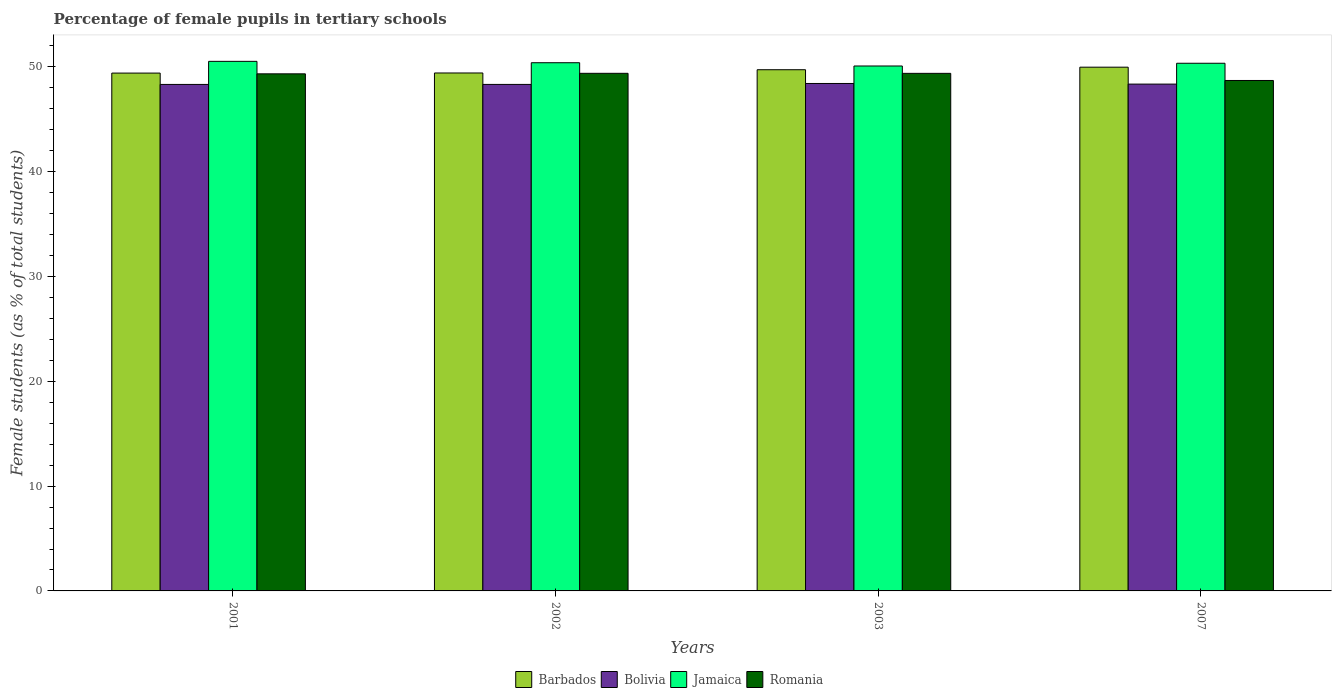Are the number of bars on each tick of the X-axis equal?
Make the answer very short. Yes. How many bars are there on the 1st tick from the left?
Your response must be concise. 4. What is the percentage of female pupils in tertiary schools in Jamaica in 2007?
Your response must be concise. 50.35. Across all years, what is the maximum percentage of female pupils in tertiary schools in Bolivia?
Provide a short and direct response. 48.42. Across all years, what is the minimum percentage of female pupils in tertiary schools in Bolivia?
Provide a succinct answer. 48.33. In which year was the percentage of female pupils in tertiary schools in Jamaica maximum?
Ensure brevity in your answer.  2001. What is the total percentage of female pupils in tertiary schools in Romania in the graph?
Offer a very short reply. 196.84. What is the difference between the percentage of female pupils in tertiary schools in Bolivia in 2003 and that in 2007?
Offer a terse response. 0.06. What is the difference between the percentage of female pupils in tertiary schools in Jamaica in 2003 and the percentage of female pupils in tertiary schools in Bolivia in 2002?
Provide a short and direct response. 1.76. What is the average percentage of female pupils in tertiary schools in Bolivia per year?
Offer a very short reply. 48.36. In the year 2003, what is the difference between the percentage of female pupils in tertiary schools in Jamaica and percentage of female pupils in tertiary schools in Romania?
Your response must be concise. 0.7. In how many years, is the percentage of female pupils in tertiary schools in Romania greater than 32 %?
Ensure brevity in your answer.  4. What is the ratio of the percentage of female pupils in tertiary schools in Bolivia in 2003 to that in 2007?
Ensure brevity in your answer.  1. What is the difference between the highest and the second highest percentage of female pupils in tertiary schools in Jamaica?
Provide a succinct answer. 0.13. What is the difference between the highest and the lowest percentage of female pupils in tertiary schools in Jamaica?
Ensure brevity in your answer.  0.44. Is it the case that in every year, the sum of the percentage of female pupils in tertiary schools in Jamaica and percentage of female pupils in tertiary schools in Bolivia is greater than the sum of percentage of female pupils in tertiary schools in Barbados and percentage of female pupils in tertiary schools in Romania?
Keep it short and to the point. Yes. What does the 3rd bar from the left in 2001 represents?
Your answer should be very brief. Jamaica. What does the 4th bar from the right in 2001 represents?
Offer a very short reply. Barbados. Is it the case that in every year, the sum of the percentage of female pupils in tertiary schools in Bolivia and percentage of female pupils in tertiary schools in Romania is greater than the percentage of female pupils in tertiary schools in Barbados?
Ensure brevity in your answer.  Yes. How many bars are there?
Give a very brief answer. 16. Are all the bars in the graph horizontal?
Provide a short and direct response. No. What is the difference between two consecutive major ticks on the Y-axis?
Your response must be concise. 10. Are the values on the major ticks of Y-axis written in scientific E-notation?
Ensure brevity in your answer.  No. Does the graph contain any zero values?
Give a very brief answer. No. Where does the legend appear in the graph?
Keep it short and to the point. Bottom center. What is the title of the graph?
Keep it short and to the point. Percentage of female pupils in tertiary schools. What is the label or title of the Y-axis?
Your answer should be compact. Female students (as % of total students). What is the Female students (as % of total students) in Barbados in 2001?
Provide a short and direct response. 49.42. What is the Female students (as % of total students) of Bolivia in 2001?
Offer a terse response. 48.33. What is the Female students (as % of total students) in Jamaica in 2001?
Offer a terse response. 50.53. What is the Female students (as % of total students) of Romania in 2001?
Your response must be concise. 49.34. What is the Female students (as % of total students) of Barbados in 2002?
Offer a terse response. 49.43. What is the Female students (as % of total students) of Bolivia in 2002?
Give a very brief answer. 48.33. What is the Female students (as % of total students) in Jamaica in 2002?
Provide a short and direct response. 50.4. What is the Female students (as % of total students) in Romania in 2002?
Offer a very short reply. 49.39. What is the Female students (as % of total students) of Barbados in 2003?
Make the answer very short. 49.74. What is the Female students (as % of total students) in Bolivia in 2003?
Your response must be concise. 48.42. What is the Female students (as % of total students) in Jamaica in 2003?
Your answer should be very brief. 50.09. What is the Female students (as % of total students) in Romania in 2003?
Offer a very short reply. 49.39. What is the Female students (as % of total students) in Barbados in 2007?
Provide a short and direct response. 49.98. What is the Female students (as % of total students) of Bolivia in 2007?
Your answer should be very brief. 48.36. What is the Female students (as % of total students) of Jamaica in 2007?
Your response must be concise. 50.35. What is the Female students (as % of total students) of Romania in 2007?
Make the answer very short. 48.71. Across all years, what is the maximum Female students (as % of total students) in Barbados?
Your answer should be very brief. 49.98. Across all years, what is the maximum Female students (as % of total students) in Bolivia?
Offer a very short reply. 48.42. Across all years, what is the maximum Female students (as % of total students) in Jamaica?
Give a very brief answer. 50.53. Across all years, what is the maximum Female students (as % of total students) in Romania?
Keep it short and to the point. 49.39. Across all years, what is the minimum Female students (as % of total students) of Barbados?
Keep it short and to the point. 49.42. Across all years, what is the minimum Female students (as % of total students) in Bolivia?
Your answer should be compact. 48.33. Across all years, what is the minimum Female students (as % of total students) in Jamaica?
Make the answer very short. 50.09. Across all years, what is the minimum Female students (as % of total students) in Romania?
Your response must be concise. 48.71. What is the total Female students (as % of total students) of Barbados in the graph?
Ensure brevity in your answer.  198.55. What is the total Female students (as % of total students) in Bolivia in the graph?
Keep it short and to the point. 193.45. What is the total Female students (as % of total students) in Jamaica in the graph?
Give a very brief answer. 201.38. What is the total Female students (as % of total students) of Romania in the graph?
Keep it short and to the point. 196.84. What is the difference between the Female students (as % of total students) of Barbados in 2001 and that in 2002?
Provide a succinct answer. -0.01. What is the difference between the Female students (as % of total students) in Bolivia in 2001 and that in 2002?
Your answer should be very brief. -0. What is the difference between the Female students (as % of total students) in Jamaica in 2001 and that in 2002?
Your response must be concise. 0.13. What is the difference between the Female students (as % of total students) of Romania in 2001 and that in 2002?
Offer a very short reply. -0.05. What is the difference between the Female students (as % of total students) in Barbados in 2001 and that in 2003?
Give a very brief answer. -0.32. What is the difference between the Female students (as % of total students) in Bolivia in 2001 and that in 2003?
Make the answer very short. -0.09. What is the difference between the Female students (as % of total students) in Jamaica in 2001 and that in 2003?
Give a very brief answer. 0.44. What is the difference between the Female students (as % of total students) of Romania in 2001 and that in 2003?
Your response must be concise. -0.05. What is the difference between the Female students (as % of total students) of Barbados in 2001 and that in 2007?
Give a very brief answer. -0.56. What is the difference between the Female students (as % of total students) of Bolivia in 2001 and that in 2007?
Keep it short and to the point. -0.03. What is the difference between the Female students (as % of total students) in Jamaica in 2001 and that in 2007?
Offer a very short reply. 0.18. What is the difference between the Female students (as % of total students) in Romania in 2001 and that in 2007?
Provide a short and direct response. 0.63. What is the difference between the Female students (as % of total students) in Barbados in 2002 and that in 2003?
Your answer should be compact. -0.31. What is the difference between the Female students (as % of total students) in Bolivia in 2002 and that in 2003?
Provide a short and direct response. -0.09. What is the difference between the Female students (as % of total students) of Jamaica in 2002 and that in 2003?
Your answer should be very brief. 0.31. What is the difference between the Female students (as % of total students) of Romania in 2002 and that in 2003?
Keep it short and to the point. 0. What is the difference between the Female students (as % of total students) in Barbados in 2002 and that in 2007?
Give a very brief answer. -0.55. What is the difference between the Female students (as % of total students) of Bolivia in 2002 and that in 2007?
Ensure brevity in your answer.  -0.03. What is the difference between the Female students (as % of total students) in Jamaica in 2002 and that in 2007?
Offer a very short reply. 0.05. What is the difference between the Female students (as % of total students) of Romania in 2002 and that in 2007?
Offer a very short reply. 0.68. What is the difference between the Female students (as % of total students) of Barbados in 2003 and that in 2007?
Your answer should be compact. -0.24. What is the difference between the Female students (as % of total students) of Bolivia in 2003 and that in 2007?
Your response must be concise. 0.06. What is the difference between the Female students (as % of total students) in Jamaica in 2003 and that in 2007?
Provide a short and direct response. -0.26. What is the difference between the Female students (as % of total students) of Romania in 2003 and that in 2007?
Give a very brief answer. 0.68. What is the difference between the Female students (as % of total students) in Barbados in 2001 and the Female students (as % of total students) in Bolivia in 2002?
Keep it short and to the point. 1.08. What is the difference between the Female students (as % of total students) in Barbados in 2001 and the Female students (as % of total students) in Jamaica in 2002?
Provide a short and direct response. -0.99. What is the difference between the Female students (as % of total students) of Barbados in 2001 and the Female students (as % of total students) of Romania in 2002?
Your answer should be very brief. 0.02. What is the difference between the Female students (as % of total students) of Bolivia in 2001 and the Female students (as % of total students) of Jamaica in 2002?
Keep it short and to the point. -2.07. What is the difference between the Female students (as % of total students) of Bolivia in 2001 and the Female students (as % of total students) of Romania in 2002?
Ensure brevity in your answer.  -1.06. What is the difference between the Female students (as % of total students) of Jamaica in 2001 and the Female students (as % of total students) of Romania in 2002?
Provide a short and direct response. 1.14. What is the difference between the Female students (as % of total students) of Barbados in 2001 and the Female students (as % of total students) of Bolivia in 2003?
Provide a short and direct response. 0.99. What is the difference between the Female students (as % of total students) in Barbados in 2001 and the Female students (as % of total students) in Jamaica in 2003?
Offer a terse response. -0.68. What is the difference between the Female students (as % of total students) in Barbados in 2001 and the Female students (as % of total students) in Romania in 2003?
Make the answer very short. 0.03. What is the difference between the Female students (as % of total students) of Bolivia in 2001 and the Female students (as % of total students) of Jamaica in 2003?
Keep it short and to the point. -1.76. What is the difference between the Female students (as % of total students) in Bolivia in 2001 and the Female students (as % of total students) in Romania in 2003?
Make the answer very short. -1.06. What is the difference between the Female students (as % of total students) in Jamaica in 2001 and the Female students (as % of total students) in Romania in 2003?
Ensure brevity in your answer.  1.14. What is the difference between the Female students (as % of total students) in Barbados in 2001 and the Female students (as % of total students) in Bolivia in 2007?
Give a very brief answer. 1.05. What is the difference between the Female students (as % of total students) in Barbados in 2001 and the Female students (as % of total students) in Jamaica in 2007?
Offer a terse response. -0.94. What is the difference between the Female students (as % of total students) of Barbados in 2001 and the Female students (as % of total students) of Romania in 2007?
Your response must be concise. 0.7. What is the difference between the Female students (as % of total students) of Bolivia in 2001 and the Female students (as % of total students) of Jamaica in 2007?
Ensure brevity in your answer.  -2.02. What is the difference between the Female students (as % of total students) of Bolivia in 2001 and the Female students (as % of total students) of Romania in 2007?
Give a very brief answer. -0.38. What is the difference between the Female students (as % of total students) in Jamaica in 2001 and the Female students (as % of total students) in Romania in 2007?
Keep it short and to the point. 1.82. What is the difference between the Female students (as % of total students) in Barbados in 2002 and the Female students (as % of total students) in Jamaica in 2003?
Ensure brevity in your answer.  -0.67. What is the difference between the Female students (as % of total students) of Barbados in 2002 and the Female students (as % of total students) of Romania in 2003?
Give a very brief answer. 0.04. What is the difference between the Female students (as % of total students) of Bolivia in 2002 and the Female students (as % of total students) of Jamaica in 2003?
Make the answer very short. -1.76. What is the difference between the Female students (as % of total students) in Bolivia in 2002 and the Female students (as % of total students) in Romania in 2003?
Offer a very short reply. -1.06. What is the difference between the Female students (as % of total students) of Jamaica in 2002 and the Female students (as % of total students) of Romania in 2003?
Keep it short and to the point. 1.01. What is the difference between the Female students (as % of total students) of Barbados in 2002 and the Female students (as % of total students) of Bolivia in 2007?
Offer a very short reply. 1.06. What is the difference between the Female students (as % of total students) in Barbados in 2002 and the Female students (as % of total students) in Jamaica in 2007?
Give a very brief answer. -0.93. What is the difference between the Female students (as % of total students) in Barbados in 2002 and the Female students (as % of total students) in Romania in 2007?
Offer a very short reply. 0.71. What is the difference between the Female students (as % of total students) in Bolivia in 2002 and the Female students (as % of total students) in Jamaica in 2007?
Keep it short and to the point. -2.02. What is the difference between the Female students (as % of total students) in Bolivia in 2002 and the Female students (as % of total students) in Romania in 2007?
Your answer should be very brief. -0.38. What is the difference between the Female students (as % of total students) in Jamaica in 2002 and the Female students (as % of total students) in Romania in 2007?
Your response must be concise. 1.69. What is the difference between the Female students (as % of total students) in Barbados in 2003 and the Female students (as % of total students) in Bolivia in 2007?
Your answer should be compact. 1.37. What is the difference between the Female students (as % of total students) in Barbados in 2003 and the Female students (as % of total students) in Jamaica in 2007?
Keep it short and to the point. -0.62. What is the difference between the Female students (as % of total students) in Barbados in 2003 and the Female students (as % of total students) in Romania in 2007?
Ensure brevity in your answer.  1.02. What is the difference between the Female students (as % of total students) in Bolivia in 2003 and the Female students (as % of total students) in Jamaica in 2007?
Your answer should be very brief. -1.93. What is the difference between the Female students (as % of total students) in Bolivia in 2003 and the Female students (as % of total students) in Romania in 2007?
Give a very brief answer. -0.29. What is the difference between the Female students (as % of total students) in Jamaica in 2003 and the Female students (as % of total students) in Romania in 2007?
Make the answer very short. 1.38. What is the average Female students (as % of total students) of Barbados per year?
Offer a very short reply. 49.64. What is the average Female students (as % of total students) of Bolivia per year?
Keep it short and to the point. 48.36. What is the average Female students (as % of total students) of Jamaica per year?
Offer a terse response. 50.35. What is the average Female students (as % of total students) of Romania per year?
Your answer should be compact. 49.21. In the year 2001, what is the difference between the Female students (as % of total students) in Barbados and Female students (as % of total students) in Bolivia?
Offer a terse response. 1.08. In the year 2001, what is the difference between the Female students (as % of total students) in Barbados and Female students (as % of total students) in Jamaica?
Provide a succinct answer. -1.12. In the year 2001, what is the difference between the Female students (as % of total students) in Barbados and Female students (as % of total students) in Romania?
Keep it short and to the point. 0.07. In the year 2001, what is the difference between the Female students (as % of total students) of Bolivia and Female students (as % of total students) of Jamaica?
Make the answer very short. -2.2. In the year 2001, what is the difference between the Female students (as % of total students) of Bolivia and Female students (as % of total students) of Romania?
Provide a succinct answer. -1.01. In the year 2001, what is the difference between the Female students (as % of total students) of Jamaica and Female students (as % of total students) of Romania?
Ensure brevity in your answer.  1.19. In the year 2002, what is the difference between the Female students (as % of total students) of Barbados and Female students (as % of total students) of Bolivia?
Offer a very short reply. 1.09. In the year 2002, what is the difference between the Female students (as % of total students) of Barbados and Female students (as % of total students) of Jamaica?
Keep it short and to the point. -0.98. In the year 2002, what is the difference between the Female students (as % of total students) in Barbados and Female students (as % of total students) in Romania?
Your response must be concise. 0.03. In the year 2002, what is the difference between the Female students (as % of total students) in Bolivia and Female students (as % of total students) in Jamaica?
Offer a very short reply. -2.07. In the year 2002, what is the difference between the Female students (as % of total students) in Bolivia and Female students (as % of total students) in Romania?
Your answer should be compact. -1.06. In the year 2002, what is the difference between the Female students (as % of total students) in Jamaica and Female students (as % of total students) in Romania?
Offer a terse response. 1.01. In the year 2003, what is the difference between the Female students (as % of total students) of Barbados and Female students (as % of total students) of Bolivia?
Provide a succinct answer. 1.31. In the year 2003, what is the difference between the Female students (as % of total students) in Barbados and Female students (as % of total students) in Jamaica?
Offer a very short reply. -0.36. In the year 2003, what is the difference between the Female students (as % of total students) of Barbados and Female students (as % of total students) of Romania?
Ensure brevity in your answer.  0.35. In the year 2003, what is the difference between the Female students (as % of total students) of Bolivia and Female students (as % of total students) of Jamaica?
Offer a terse response. -1.67. In the year 2003, what is the difference between the Female students (as % of total students) in Bolivia and Female students (as % of total students) in Romania?
Keep it short and to the point. -0.97. In the year 2003, what is the difference between the Female students (as % of total students) of Jamaica and Female students (as % of total students) of Romania?
Keep it short and to the point. 0.7. In the year 2007, what is the difference between the Female students (as % of total students) of Barbados and Female students (as % of total students) of Bolivia?
Your answer should be compact. 1.61. In the year 2007, what is the difference between the Female students (as % of total students) in Barbados and Female students (as % of total students) in Jamaica?
Your response must be concise. -0.37. In the year 2007, what is the difference between the Female students (as % of total students) of Barbados and Female students (as % of total students) of Romania?
Your response must be concise. 1.27. In the year 2007, what is the difference between the Female students (as % of total students) of Bolivia and Female students (as % of total students) of Jamaica?
Offer a very short reply. -1.99. In the year 2007, what is the difference between the Female students (as % of total students) of Bolivia and Female students (as % of total students) of Romania?
Your answer should be compact. -0.35. In the year 2007, what is the difference between the Female students (as % of total students) in Jamaica and Female students (as % of total students) in Romania?
Provide a short and direct response. 1.64. What is the ratio of the Female students (as % of total students) in Barbados in 2001 to that in 2002?
Ensure brevity in your answer.  1. What is the ratio of the Female students (as % of total students) of Jamaica in 2001 to that in 2002?
Offer a very short reply. 1. What is the ratio of the Female students (as % of total students) in Romania in 2001 to that in 2002?
Give a very brief answer. 1. What is the ratio of the Female students (as % of total students) in Bolivia in 2001 to that in 2003?
Your answer should be very brief. 1. What is the ratio of the Female students (as % of total students) in Jamaica in 2001 to that in 2003?
Give a very brief answer. 1.01. What is the ratio of the Female students (as % of total students) in Romania in 2001 to that in 2003?
Your response must be concise. 1. What is the ratio of the Female students (as % of total students) of Barbados in 2001 to that in 2007?
Keep it short and to the point. 0.99. What is the ratio of the Female students (as % of total students) of Barbados in 2002 to that in 2003?
Your response must be concise. 0.99. What is the ratio of the Female students (as % of total students) in Jamaica in 2002 to that in 2003?
Your answer should be compact. 1.01. What is the ratio of the Female students (as % of total students) of Romania in 2002 to that in 2003?
Make the answer very short. 1. What is the ratio of the Female students (as % of total students) of Barbados in 2002 to that in 2007?
Offer a terse response. 0.99. What is the ratio of the Female students (as % of total students) in Bolivia in 2002 to that in 2007?
Your answer should be compact. 1. What is the ratio of the Female students (as % of total students) in Barbados in 2003 to that in 2007?
Keep it short and to the point. 1. What is the ratio of the Female students (as % of total students) in Bolivia in 2003 to that in 2007?
Provide a succinct answer. 1. What is the ratio of the Female students (as % of total students) of Jamaica in 2003 to that in 2007?
Offer a terse response. 0.99. What is the ratio of the Female students (as % of total students) of Romania in 2003 to that in 2007?
Provide a succinct answer. 1.01. What is the difference between the highest and the second highest Female students (as % of total students) in Barbados?
Offer a very short reply. 0.24. What is the difference between the highest and the second highest Female students (as % of total students) in Bolivia?
Your answer should be compact. 0.06. What is the difference between the highest and the second highest Female students (as % of total students) of Jamaica?
Offer a very short reply. 0.13. What is the difference between the highest and the second highest Female students (as % of total students) in Romania?
Provide a succinct answer. 0. What is the difference between the highest and the lowest Female students (as % of total students) in Barbados?
Provide a succinct answer. 0.56. What is the difference between the highest and the lowest Female students (as % of total students) of Bolivia?
Your answer should be compact. 0.09. What is the difference between the highest and the lowest Female students (as % of total students) in Jamaica?
Offer a very short reply. 0.44. What is the difference between the highest and the lowest Female students (as % of total students) of Romania?
Provide a short and direct response. 0.68. 